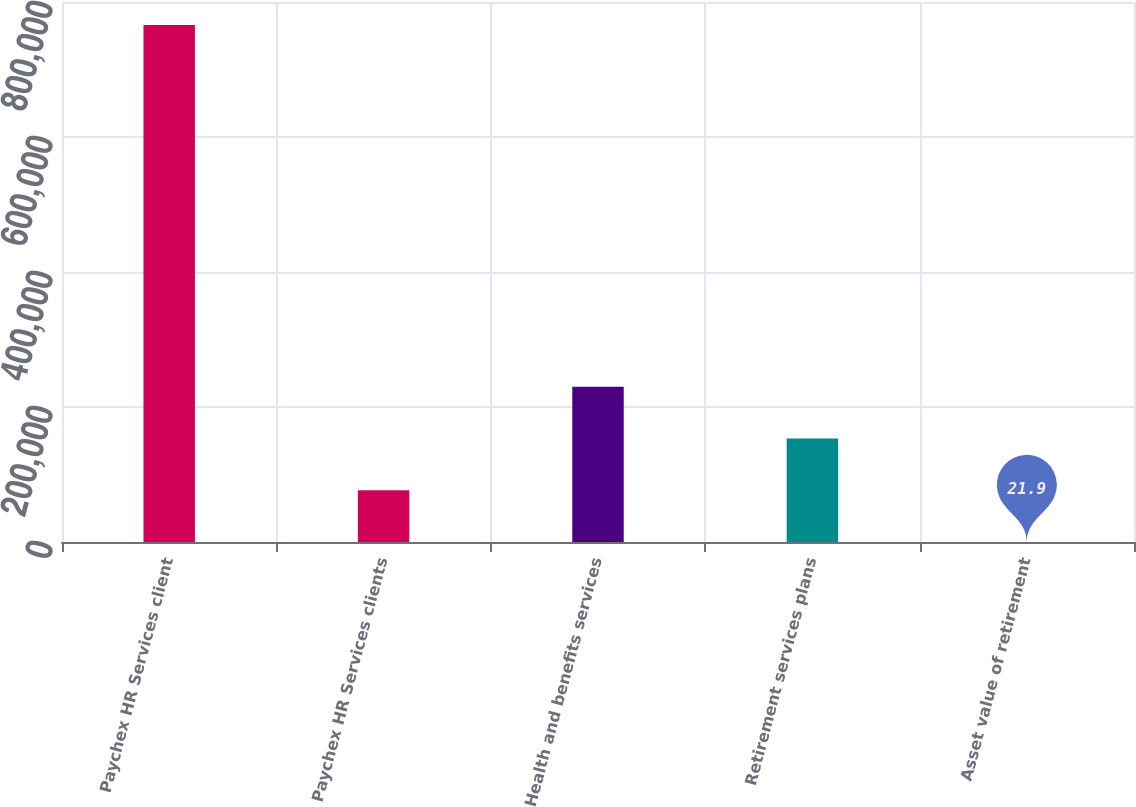Convert chart to OTSL. <chart><loc_0><loc_0><loc_500><loc_500><bar_chart><fcel>Paychex HR Services client<fcel>Paychex HR Services clients<fcel>Health and benefits services<fcel>Retirement services plans<fcel>Asset value of retirement<nl><fcel>766000<fcel>76619.7<fcel>229815<fcel>153218<fcel>21.9<nl></chart> 